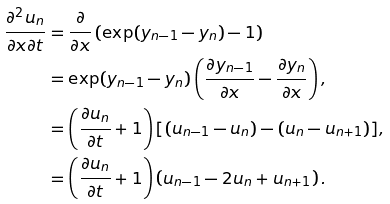Convert formula to latex. <formula><loc_0><loc_0><loc_500><loc_500>\frac { \partial ^ { 2 } u _ { n } } { \partial x \partial t } & = \frac { \partial } { \partial x } \left ( \exp ( y _ { n - 1 } - y _ { n } ) - 1 \right ) \\ & = \exp ( y _ { n - 1 } - y _ { n } ) \left ( \frac { \partial y _ { n - 1 } } { \partial x } - \frac { \partial y _ { n } } { \partial x } \right ) , \\ & = \left ( \frac { \partial u _ { n } } { \partial t } + 1 \right ) [ ( u _ { n - 1 } - u _ { n } ) - ( u _ { n } - u _ { n + 1 } ) ] , \\ & = \left ( \frac { \partial u _ { n } } { \partial t } + 1 \right ) \left ( u _ { n - 1 } - 2 u _ { n } + u _ { n + 1 } \right ) .</formula> 